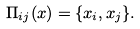Convert formula to latex. <formula><loc_0><loc_0><loc_500><loc_500>\Pi _ { i j } ( x ) = \{ x _ { i } , x _ { j } \} .</formula> 